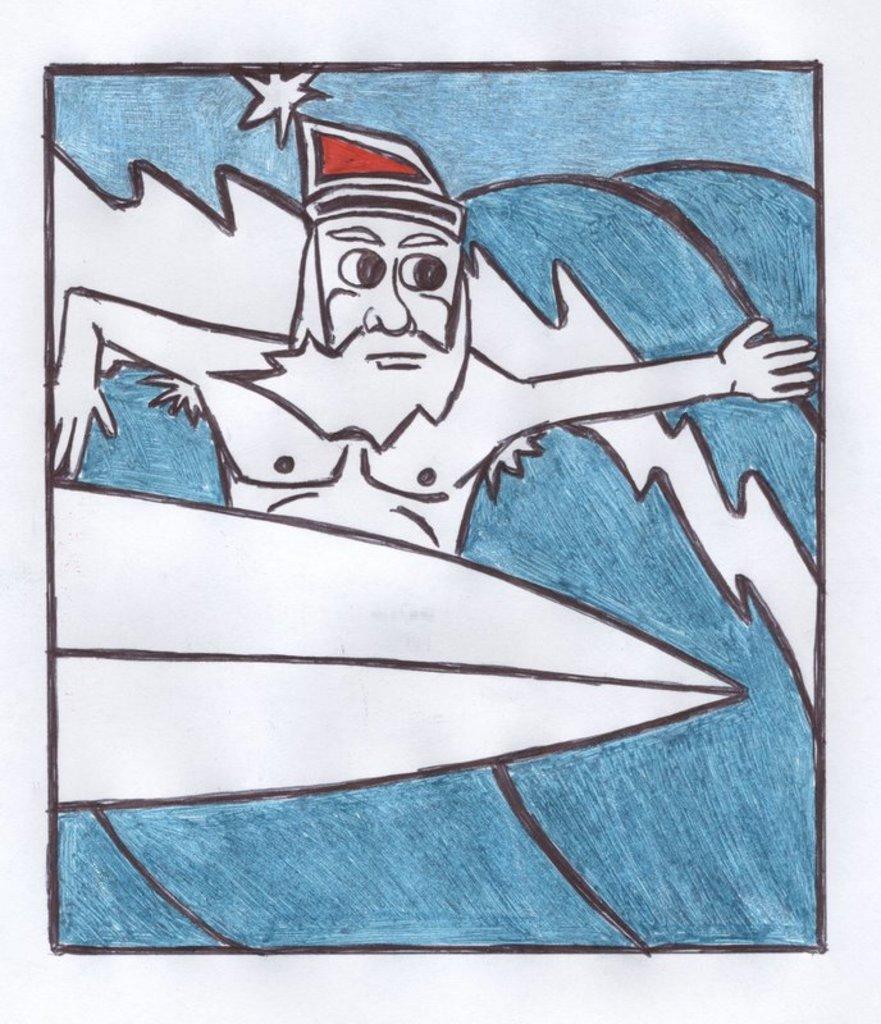Please provide a concise description of this image. In the picture I can see sketch of a person who is surfing. 